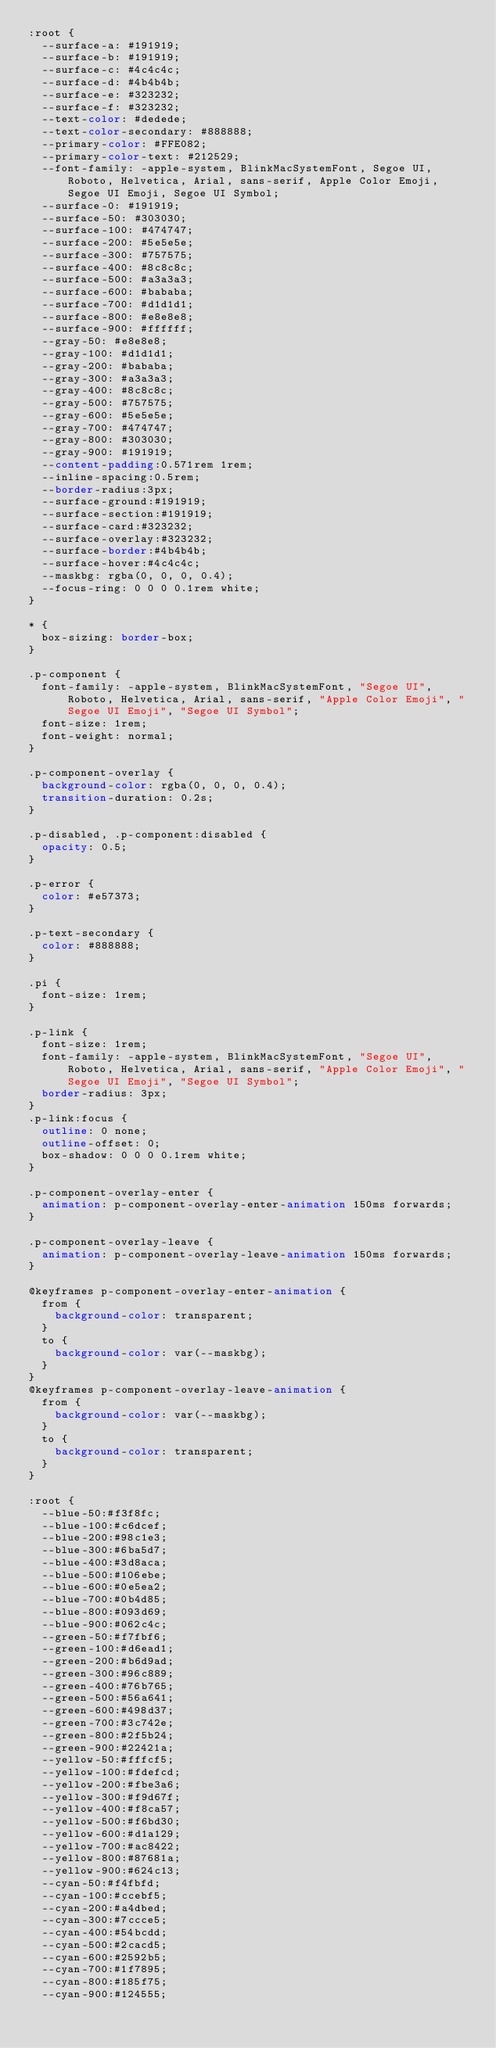Convert code to text. <code><loc_0><loc_0><loc_500><loc_500><_CSS_>:root {
  --surface-a: #191919;
  --surface-b: #191919;
  --surface-c: #4c4c4c;
  --surface-d: #4b4b4b;
  --surface-e: #323232;
  --surface-f: #323232;
  --text-color: #dedede;
  --text-color-secondary: #888888;
  --primary-color: #FFE082;
  --primary-color-text: #212529;
  --font-family: -apple-system, BlinkMacSystemFont, Segoe UI, Roboto, Helvetica, Arial, sans-serif, Apple Color Emoji, Segoe UI Emoji, Segoe UI Symbol;
  --surface-0: #191919;
  --surface-50: #303030;
  --surface-100: #474747;
  --surface-200: #5e5e5e;
  --surface-300: #757575;
  --surface-400: #8c8c8c;
  --surface-500: #a3a3a3;
  --surface-600: #bababa;
  --surface-700: #d1d1d1;
  --surface-800: #e8e8e8;
  --surface-900: #ffffff;
  --gray-50: #e8e8e8;
  --gray-100: #d1d1d1;
  --gray-200: #bababa;
  --gray-300: #a3a3a3;
  --gray-400: #8c8c8c;
  --gray-500: #757575;
  --gray-600: #5e5e5e;
  --gray-700: #474747;
  --gray-800: #303030;
  --gray-900: #191919;
  --content-padding:0.571rem 1rem;
  --inline-spacing:0.5rem;
  --border-radius:3px;
  --surface-ground:#191919;
  --surface-section:#191919;
  --surface-card:#323232;
  --surface-overlay:#323232;
  --surface-border:#4b4b4b;
  --surface-hover:#4c4c4c;
  --maskbg: rgba(0, 0, 0, 0.4);
  --focus-ring: 0 0 0 0.1rem white;
}

* {
  box-sizing: border-box;
}

.p-component {
  font-family: -apple-system, BlinkMacSystemFont, "Segoe UI", Roboto, Helvetica, Arial, sans-serif, "Apple Color Emoji", "Segoe UI Emoji", "Segoe UI Symbol";
  font-size: 1rem;
  font-weight: normal;
}

.p-component-overlay {
  background-color: rgba(0, 0, 0, 0.4);
  transition-duration: 0.2s;
}

.p-disabled, .p-component:disabled {
  opacity: 0.5;
}

.p-error {
  color: #e57373;
}

.p-text-secondary {
  color: #888888;
}

.pi {
  font-size: 1rem;
}

.p-link {
  font-size: 1rem;
  font-family: -apple-system, BlinkMacSystemFont, "Segoe UI", Roboto, Helvetica, Arial, sans-serif, "Apple Color Emoji", "Segoe UI Emoji", "Segoe UI Symbol";
  border-radius: 3px;
}
.p-link:focus {
  outline: 0 none;
  outline-offset: 0;
  box-shadow: 0 0 0 0.1rem white;
}

.p-component-overlay-enter {
  animation: p-component-overlay-enter-animation 150ms forwards;
}

.p-component-overlay-leave {
  animation: p-component-overlay-leave-animation 150ms forwards;
}

@keyframes p-component-overlay-enter-animation {
  from {
    background-color: transparent;
  }
  to {
    background-color: var(--maskbg);
  }
}
@keyframes p-component-overlay-leave-animation {
  from {
    background-color: var(--maskbg);
  }
  to {
    background-color: transparent;
  }
}

:root {
  --blue-50:#f3f8fc;
  --blue-100:#c6dcef;
  --blue-200:#98c1e3;
  --blue-300:#6ba5d7;
  --blue-400:#3d8aca;
  --blue-500:#106ebe;
  --blue-600:#0e5ea2;
  --blue-700:#0b4d85;
  --blue-800:#093d69;
  --blue-900:#062c4c;
  --green-50:#f7fbf6;
  --green-100:#d6ead1;
  --green-200:#b6d9ad;
  --green-300:#96c889;
  --green-400:#76b765;
  --green-500:#56a641;
  --green-600:#498d37;
  --green-700:#3c742e;
  --green-800:#2f5b24;
  --green-900:#22421a;
  --yellow-50:#fffcf5;
  --yellow-100:#fdefcd;
  --yellow-200:#fbe3a6;
  --yellow-300:#f9d67f;
  --yellow-400:#f8ca57;
  --yellow-500:#f6bd30;
  --yellow-600:#d1a129;
  --yellow-700:#ac8422;
  --yellow-800:#87681a;
  --yellow-900:#624c13;
  --cyan-50:#f4fbfd;
  --cyan-100:#ccebf5;
  --cyan-200:#a4dbed;
  --cyan-300:#7ccce5;
  --cyan-400:#54bcdd;
  --cyan-500:#2cacd5;
  --cyan-600:#2592b5;
  --cyan-700:#1f7895;
  --cyan-800:#185f75;
  --cyan-900:#124555;</code> 